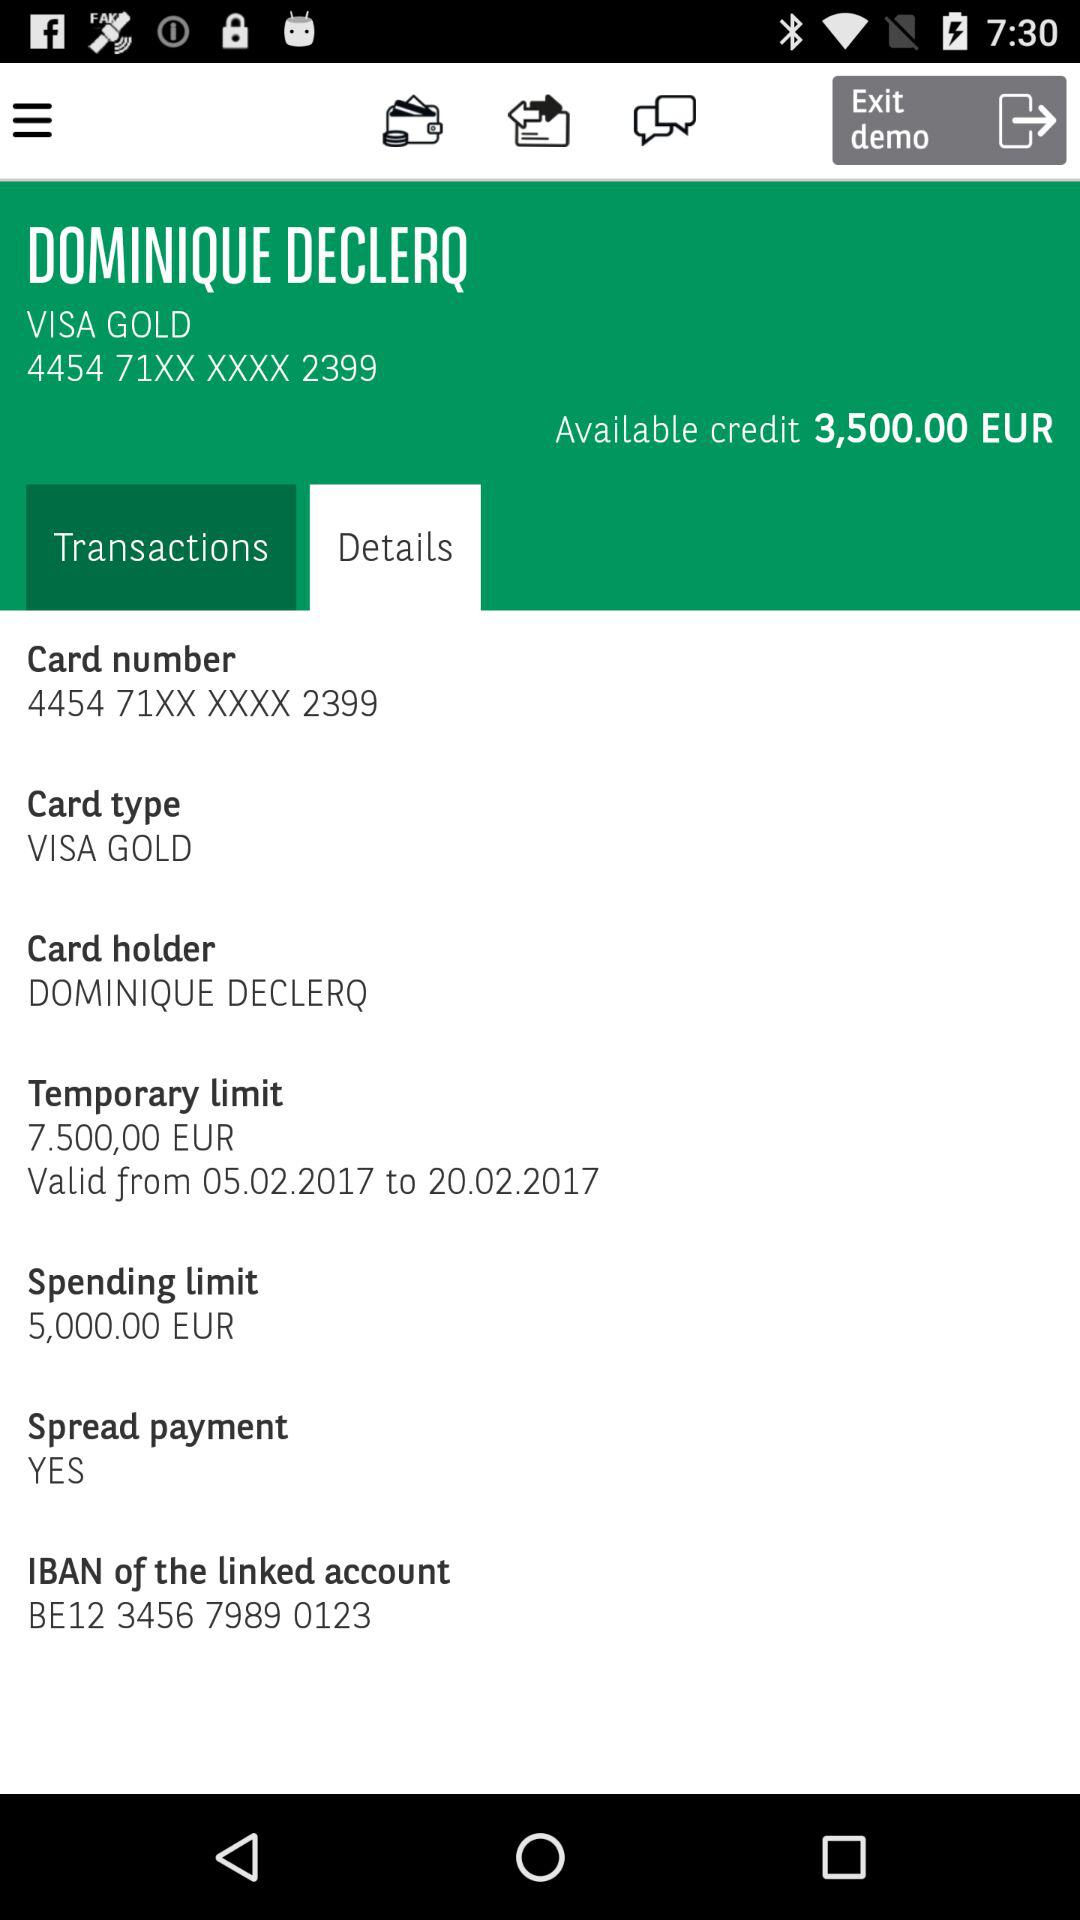Which tab is selected? The selected tab is "Details". 